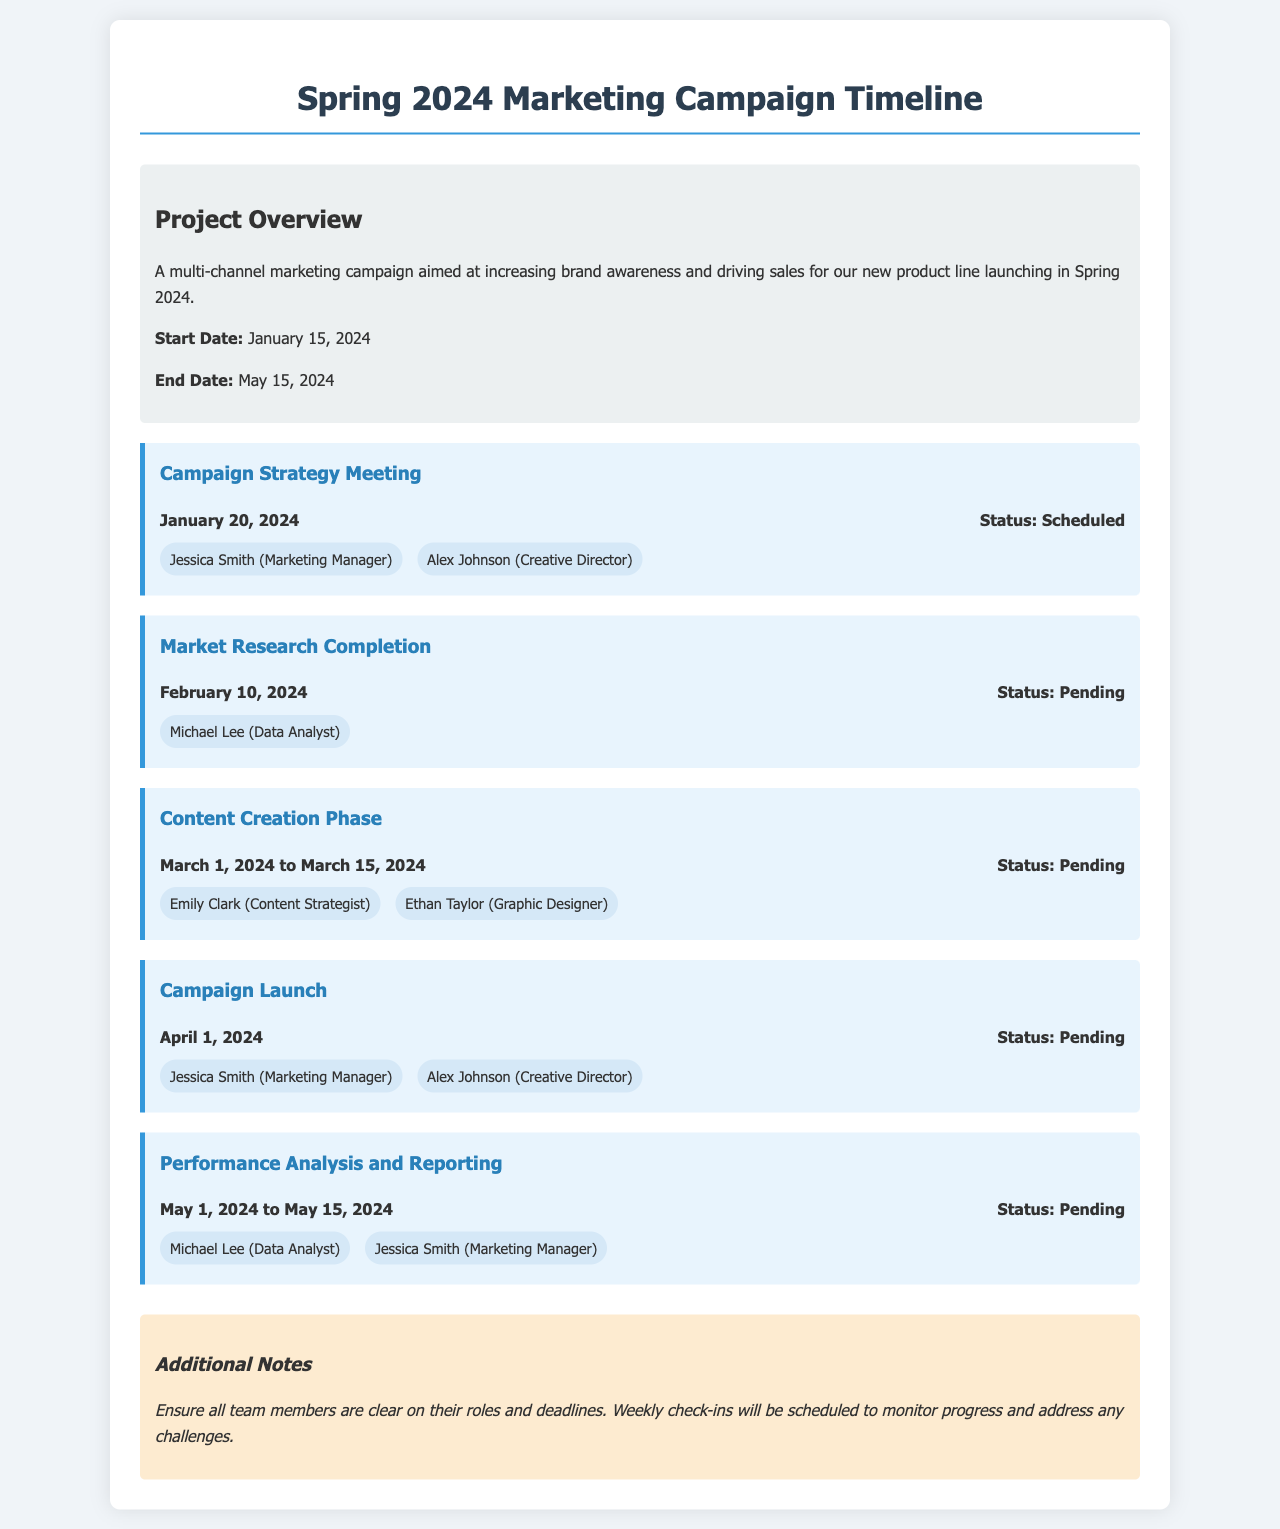what is the project start date? The project start date is specified in the project overview section of the document.
Answer: January 15, 2024 who is responsible for the Campaign Strategy Meeting? The responsibilities listed under the Campaign Strategy Meeting milestone identify the individuals involved.
Answer: Jessica Smith, Alex Johnson what is the status of the Market Research Completion milestone? The status is provided next to the milestone's date in the document.
Answer: Pending when does the Content Creation Phase occur? The dates for the Content Creation Phase are clearly stated in the milestone details.
Answer: March 1, 2024 to March 15, 2024 which milestone involves the Data Analyst? By looking at the responsibilities under each milestone, we can determine where the Data Analyst is involved.
Answer: Market Research Completion, Performance Analysis and Reporting what is the final milestone in the timeline? The last milestone is the one listed at the end of the timeline section.
Answer: Performance Analysis and Reporting how long is the project duration in days? The project duration is calculated by counting the days from the start date to the end date listed in the overview.
Answer: 120 days what is mentioned in the Additional Notes section? The Additional Notes section contains specific instructions for the team.
Answer: Ensure all team members are clear on their roles and deadlines 